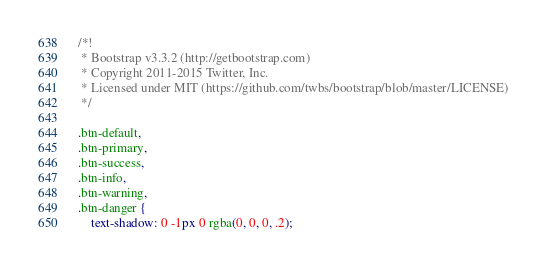<code> <loc_0><loc_0><loc_500><loc_500><_CSS_>/*!
 * Bootstrap v3.3.2 (http://getbootstrap.com)
 * Copyright 2011-2015 Twitter, Inc.
 * Licensed under MIT (https://github.com/twbs/bootstrap/blob/master/LICENSE)
 */

.btn-default,
.btn-primary,
.btn-success,
.btn-info,
.btn-warning,
.btn-danger {
    text-shadow: 0 -1px 0 rgba(0, 0, 0, .2);</code> 